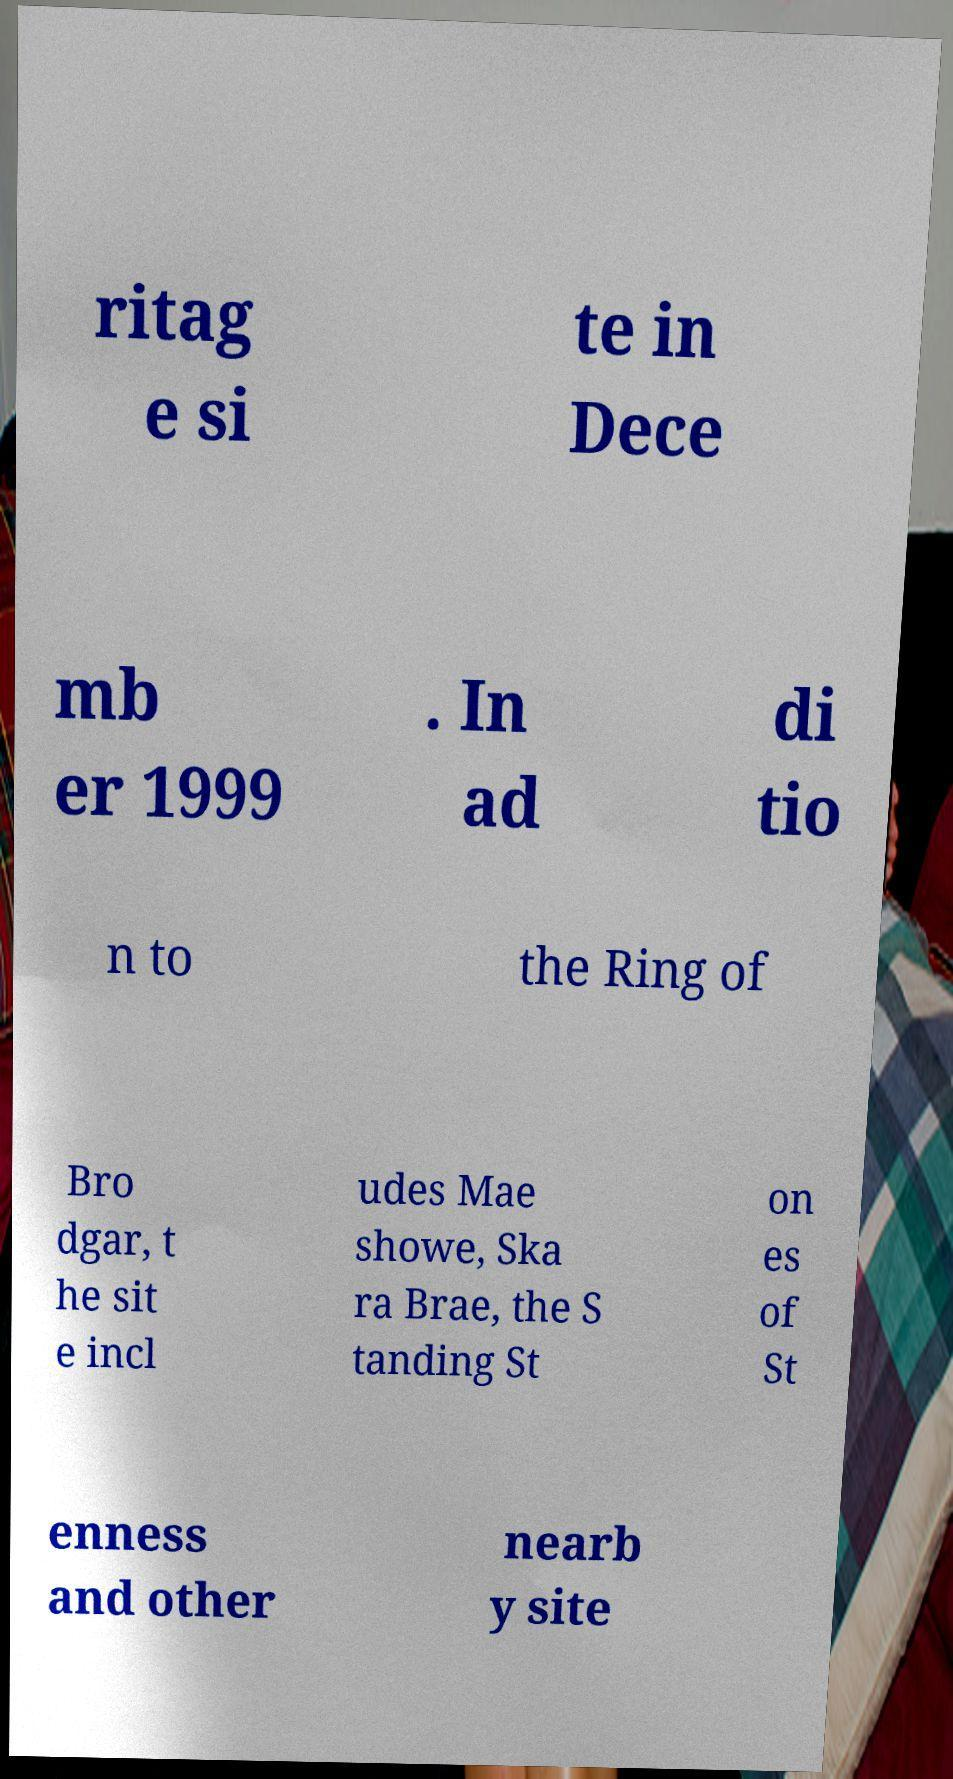Could you assist in decoding the text presented in this image and type it out clearly? ritag e si te in Dece mb er 1999 . In ad di tio n to the Ring of Bro dgar, t he sit e incl udes Mae showe, Ska ra Brae, the S tanding St on es of St enness and other nearb y site 